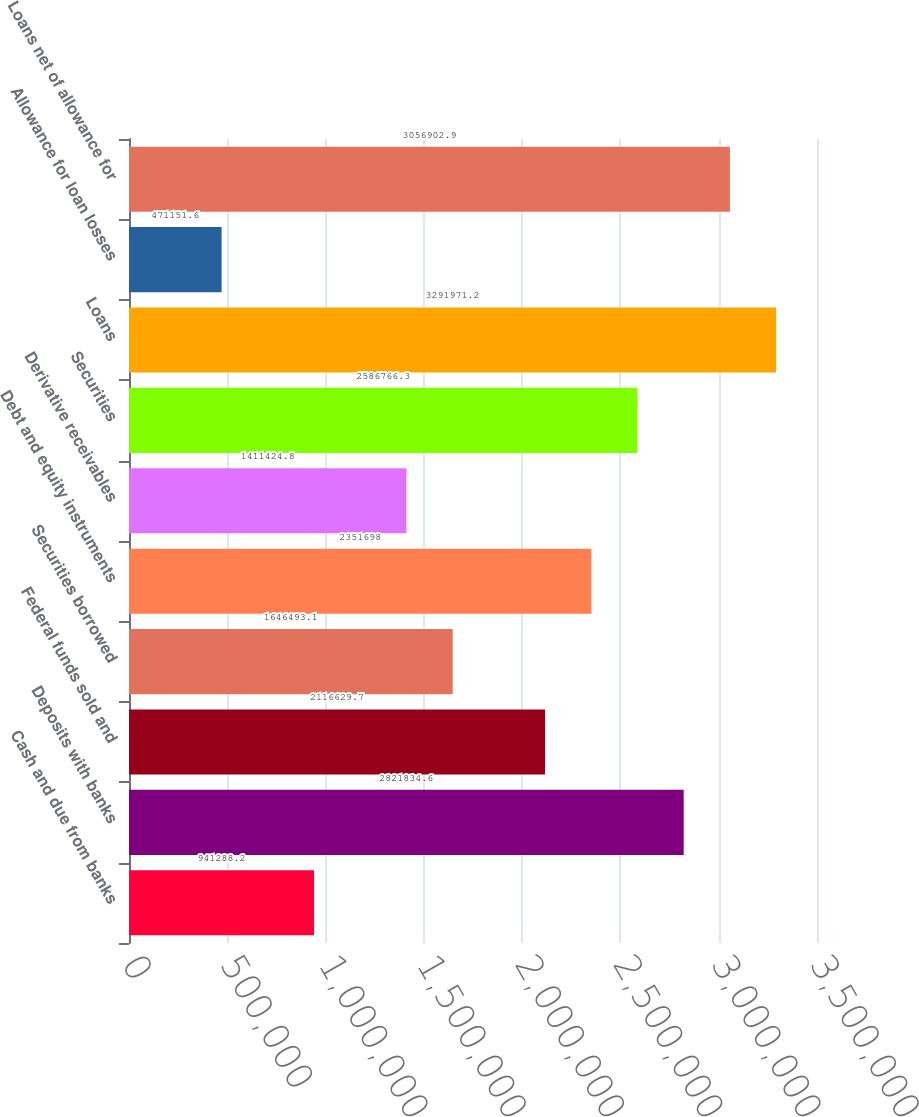Convert chart to OTSL. <chart><loc_0><loc_0><loc_500><loc_500><bar_chart><fcel>Cash and due from banks<fcel>Deposits with banks<fcel>Federal funds sold and<fcel>Securities borrowed<fcel>Debt and equity instruments<fcel>Derivative receivables<fcel>Securities<fcel>Loans<fcel>Allowance for loan losses<fcel>Loans net of allowance for<nl><fcel>941288<fcel>2.82183e+06<fcel>2.11663e+06<fcel>1.64649e+06<fcel>2.3517e+06<fcel>1.41142e+06<fcel>2.58677e+06<fcel>3.29197e+06<fcel>471152<fcel>3.0569e+06<nl></chart> 